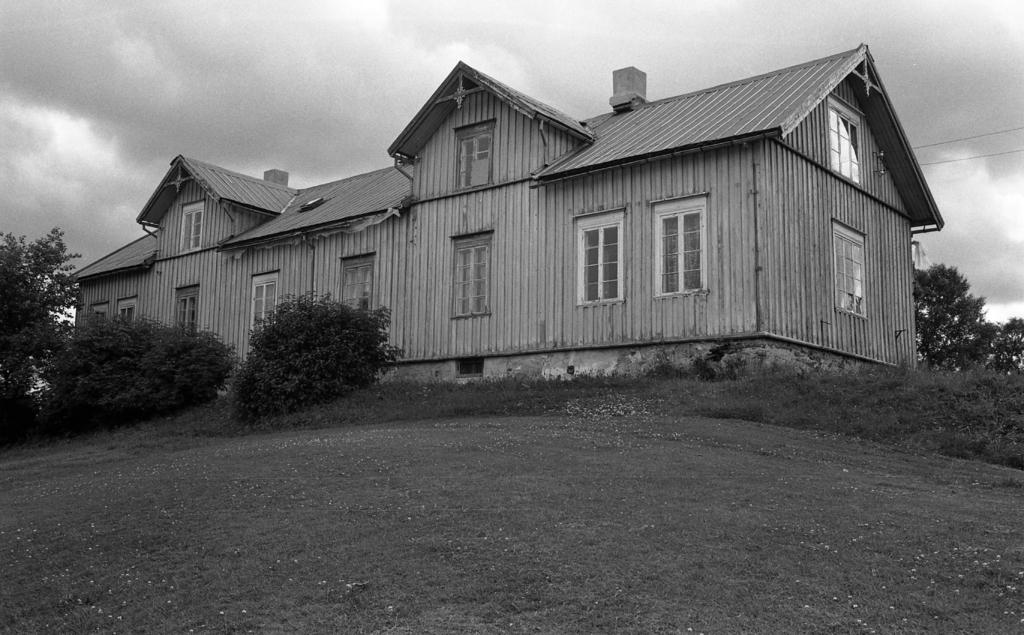What type of structure is in the image? There is a house in the image. What feature of the house is mentioned in the facts? The house has windows. What else can be seen in the image besides the house? There are trees in the image. What can be seen in the background of the image? The sky is visible in the background of the image. How is the image presented in terms of color? The image is in black and white. Where are the straws stored in the image? There are no straws present in the image. How many horses can be seen in the image? There are no horses present in the image. 